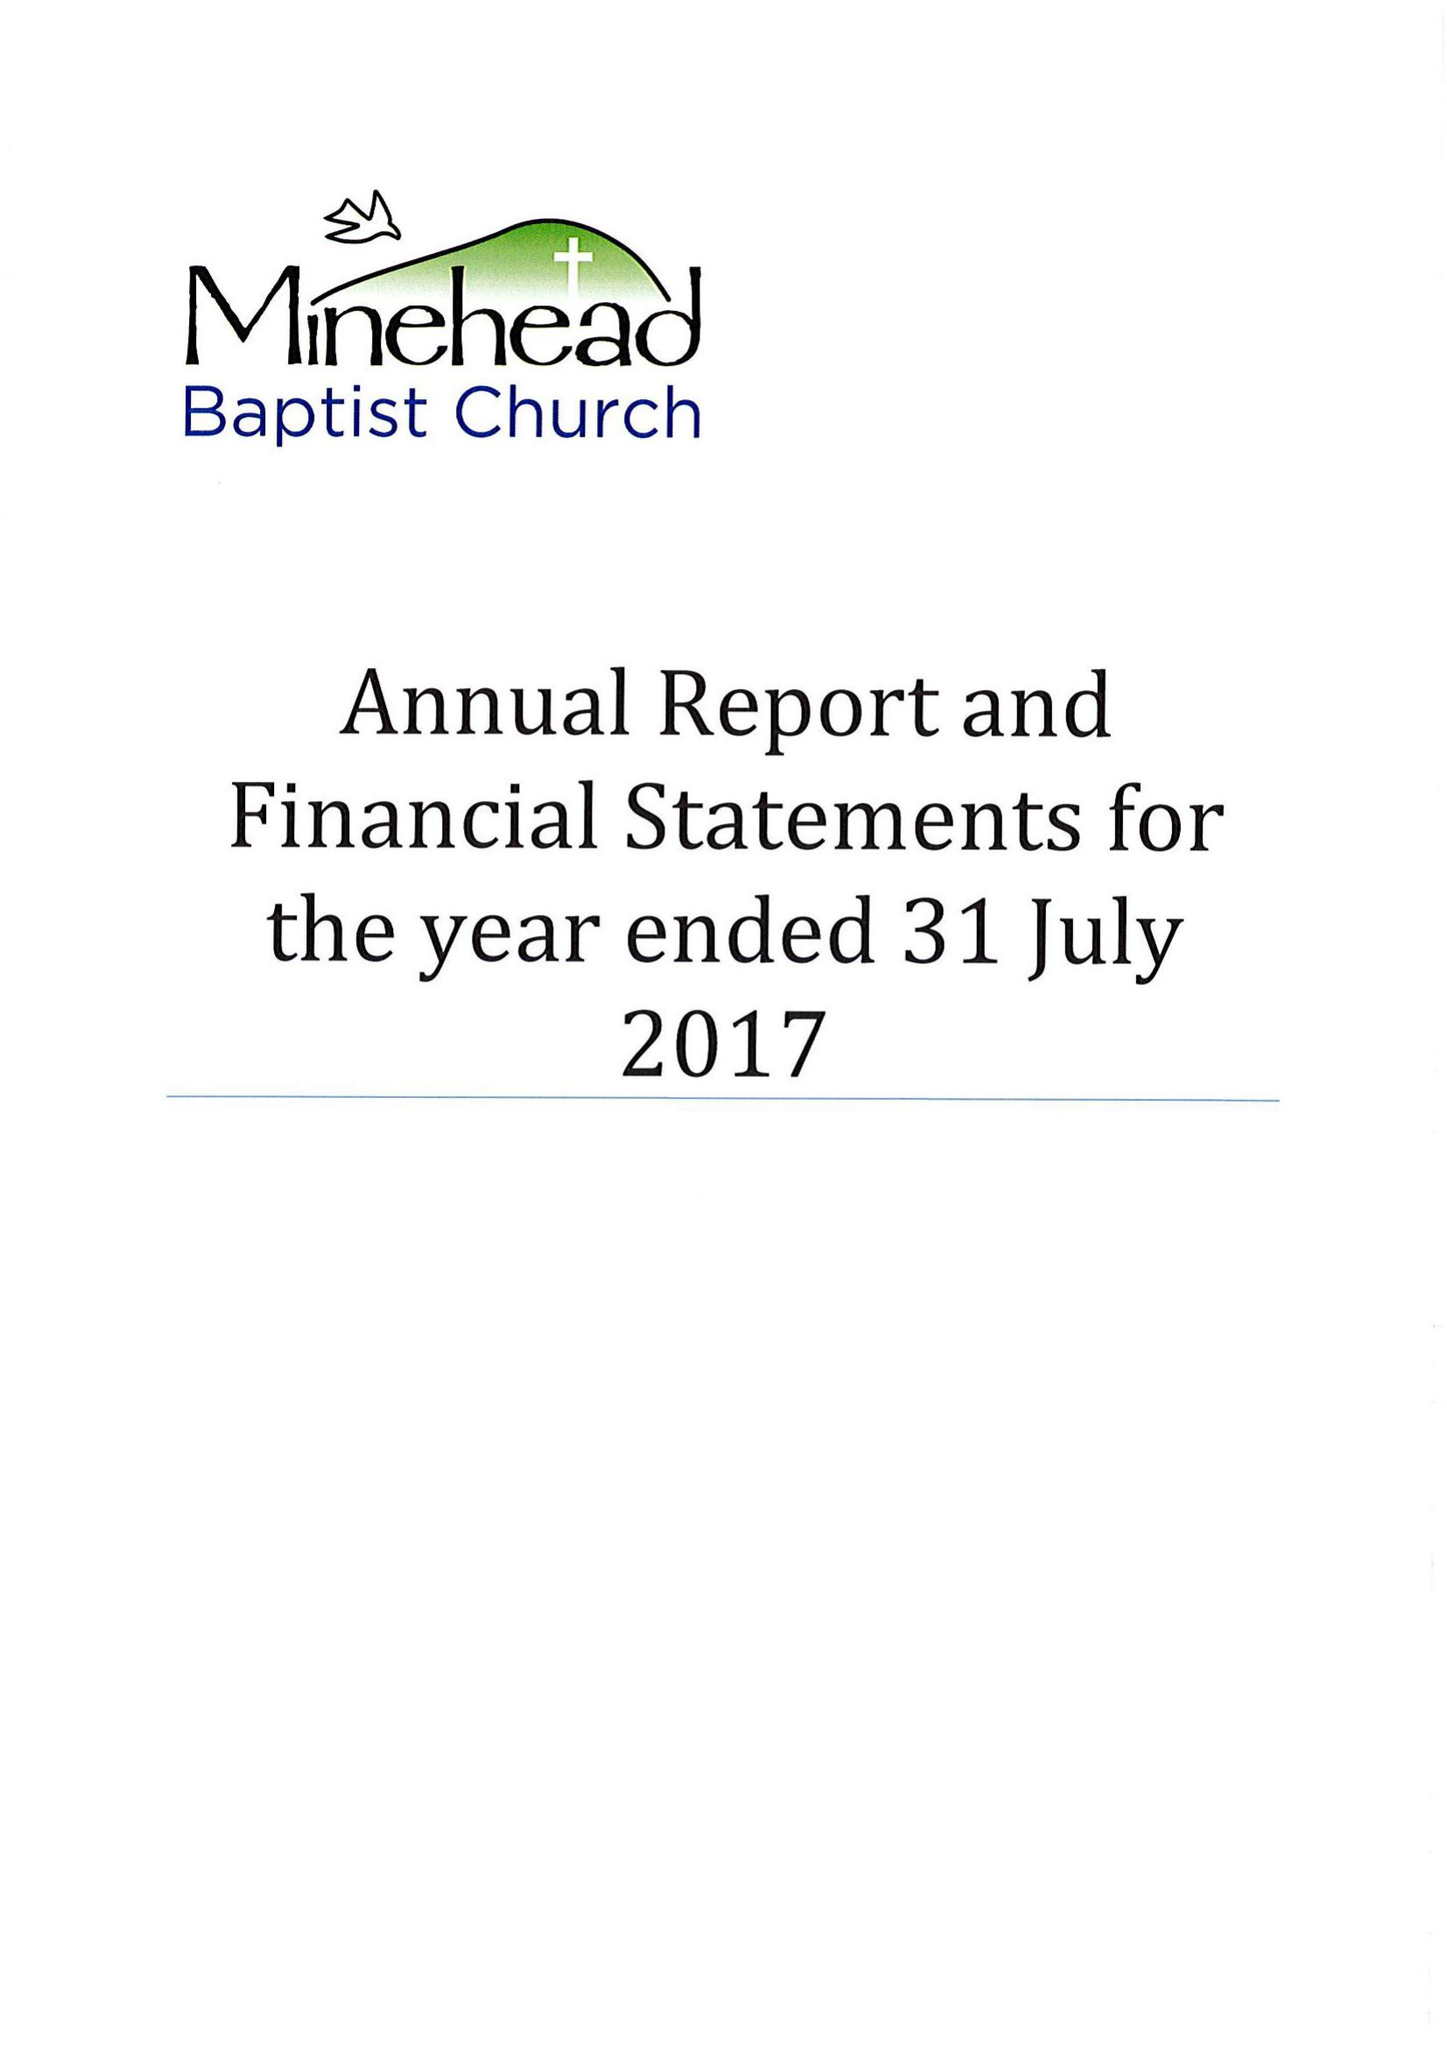What is the value for the charity_name?
Answer the question using a single word or phrase. Minehead Baptist Church 